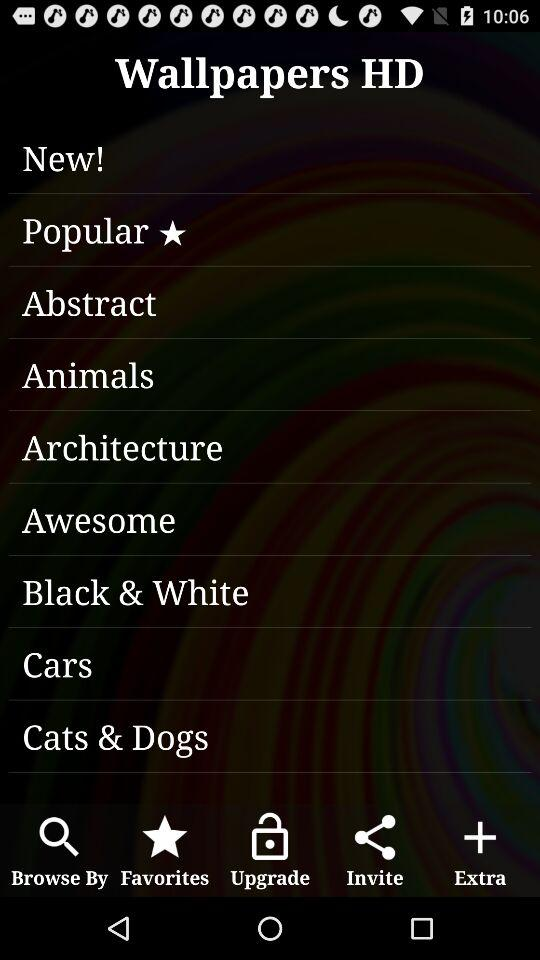Which option is marked as a favorite? The option that is marked as a favorite is "Popular". 